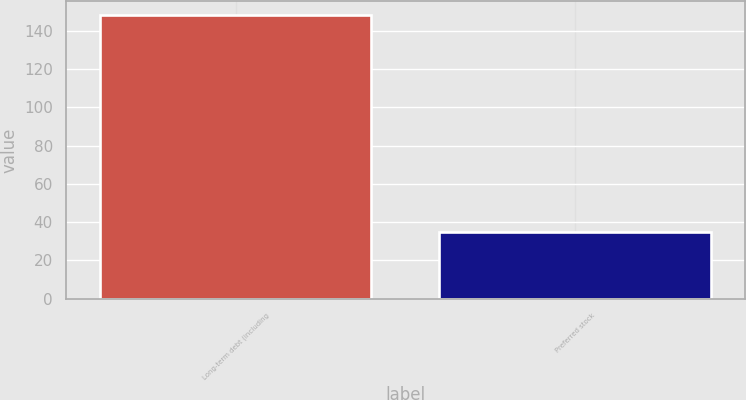<chart> <loc_0><loc_0><loc_500><loc_500><bar_chart><fcel>Long-term debt (including<fcel>Preferred stock<nl><fcel>148<fcel>35<nl></chart> 